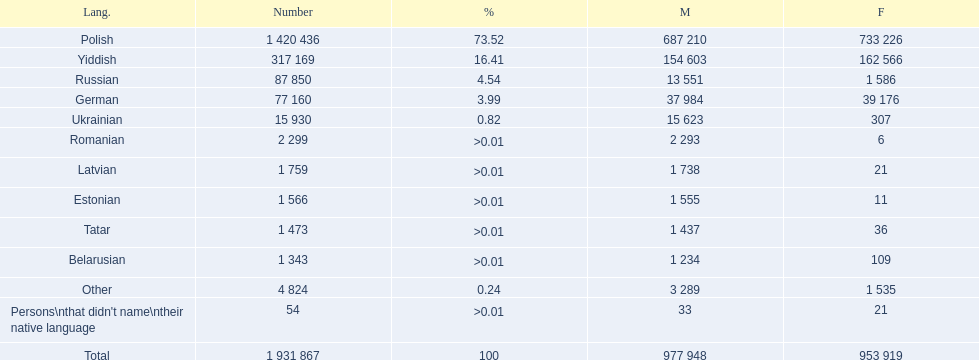Which language had the least female speakers? Romanian. 